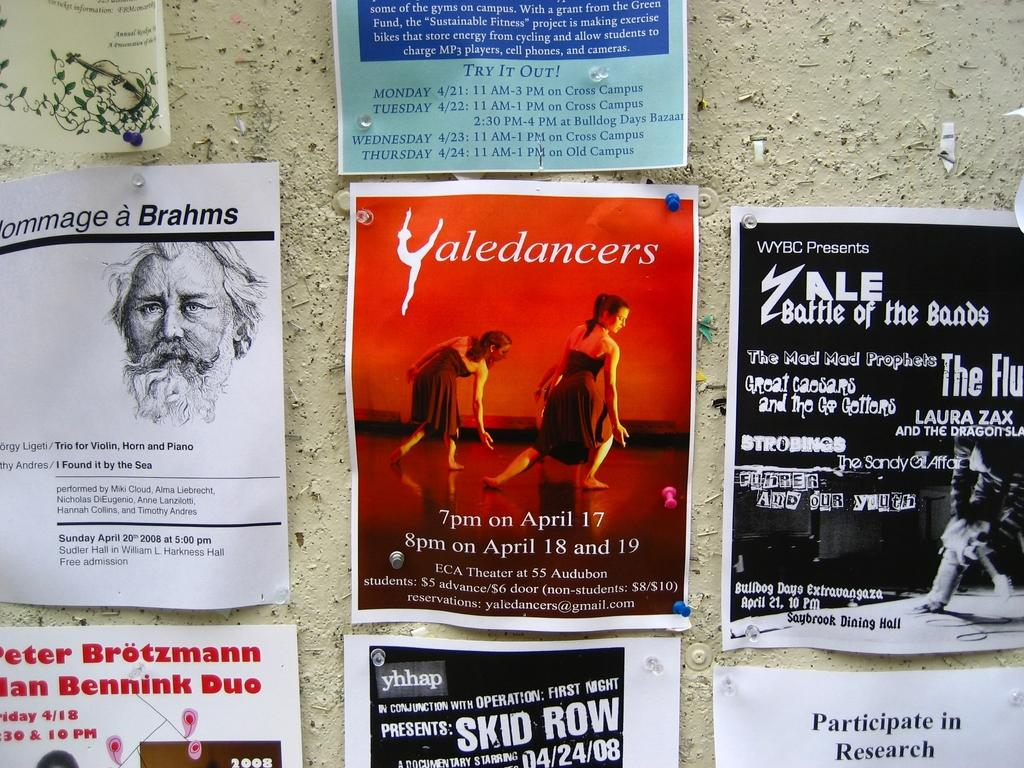<image>
Write a terse but informative summary of the picture. A wall filled with flyers from different places with a center poster reading Yaledancers 